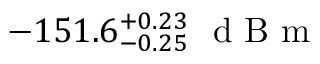Convert formula to latex. <formula><loc_0><loc_0><loc_500><loc_500>- 1 5 1 . 6 _ { - 0 . 2 5 } ^ { + 0 . 2 3 } \ d B m</formula> 